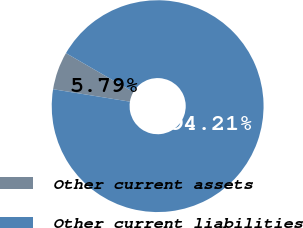Convert chart. <chart><loc_0><loc_0><loc_500><loc_500><pie_chart><fcel>Other current assets<fcel>Other current liabilities<nl><fcel>5.79%<fcel>94.21%<nl></chart> 